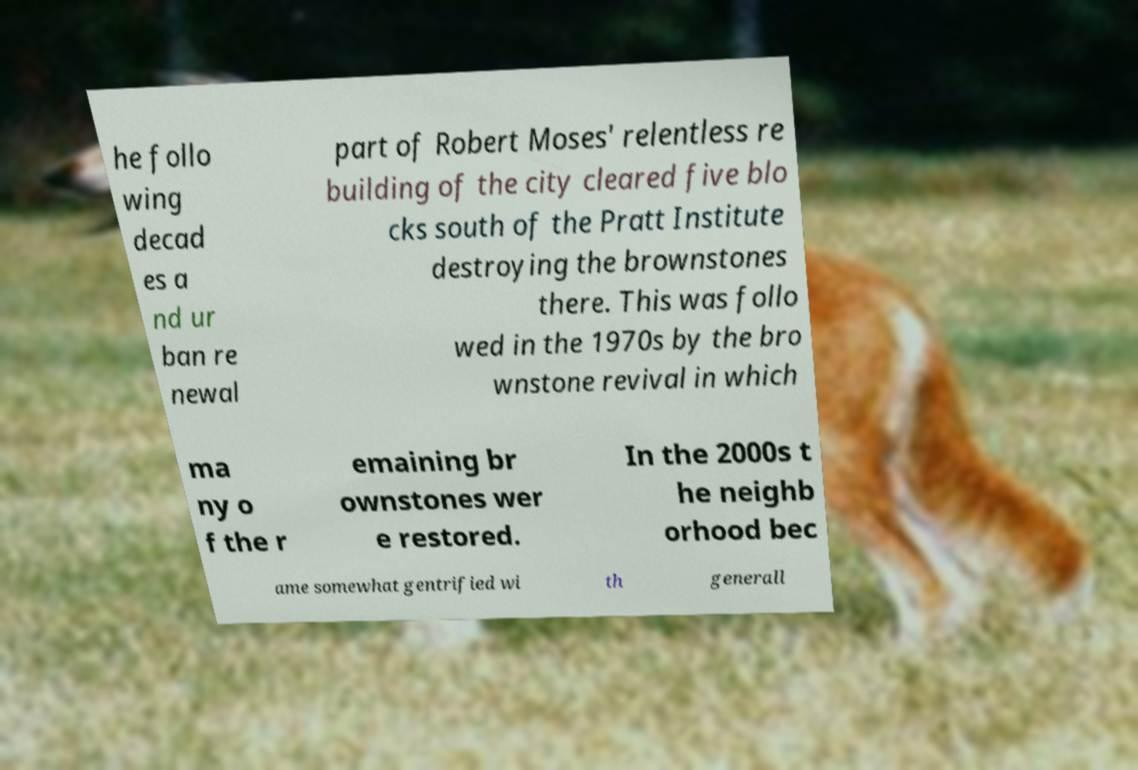I need the written content from this picture converted into text. Can you do that? he follo wing decad es a nd ur ban re newal part of Robert Moses' relentless re building of the city cleared five blo cks south of the Pratt Institute destroying the brownstones there. This was follo wed in the 1970s by the bro wnstone revival in which ma ny o f the r emaining br ownstones wer e restored. In the 2000s t he neighb orhood bec ame somewhat gentrified wi th generall 